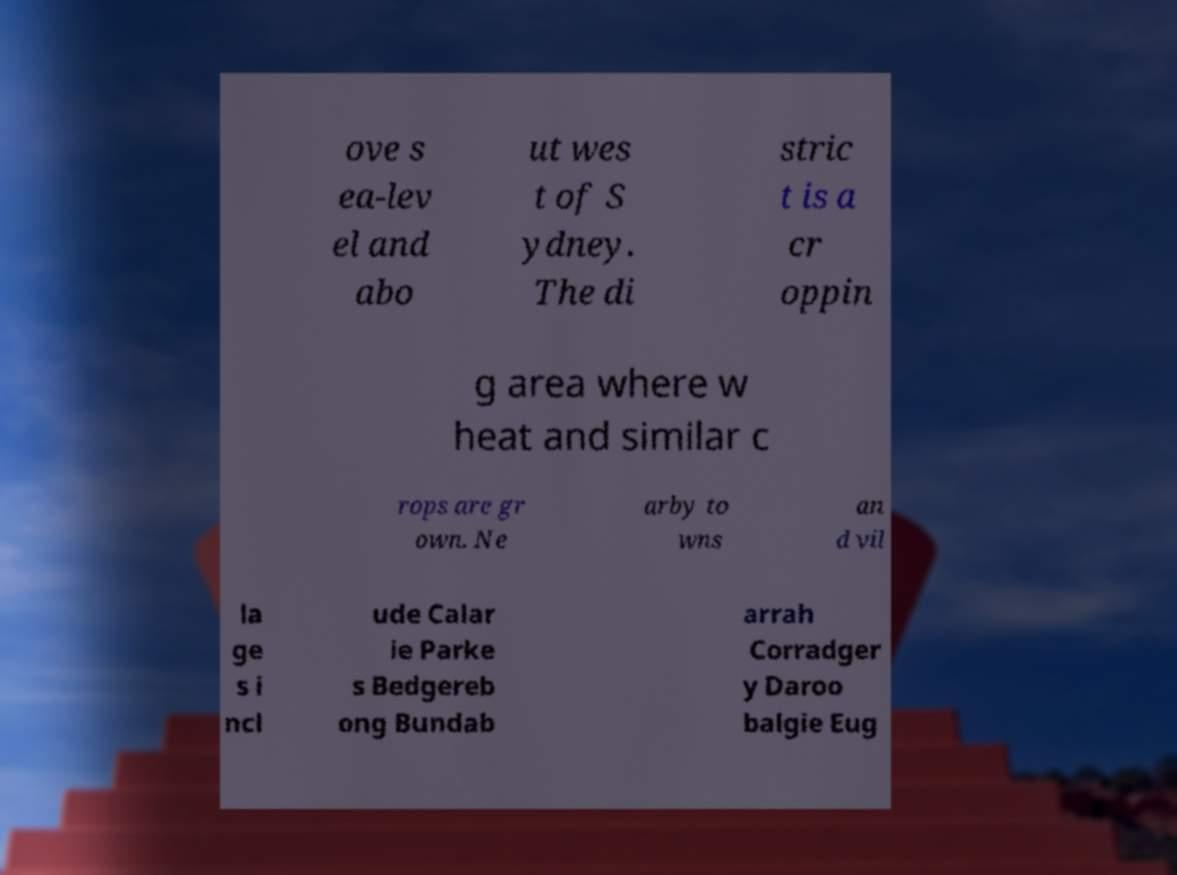What messages or text are displayed in this image? I need them in a readable, typed format. ove s ea-lev el and abo ut wes t of S ydney. The di stric t is a cr oppin g area where w heat and similar c rops are gr own. Ne arby to wns an d vil la ge s i ncl ude Calar ie Parke s Bedgereb ong Bundab arrah Corradger y Daroo balgie Eug 